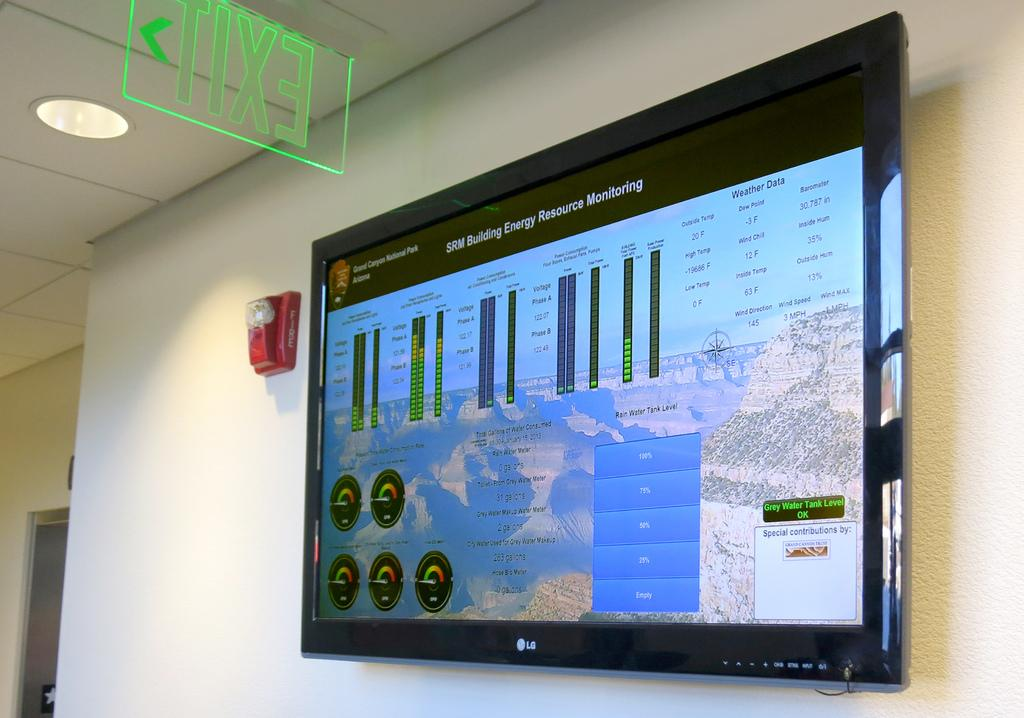<image>
Provide a brief description of the given image. a screen mounted on a wall with the word EXIT written backwards above it 